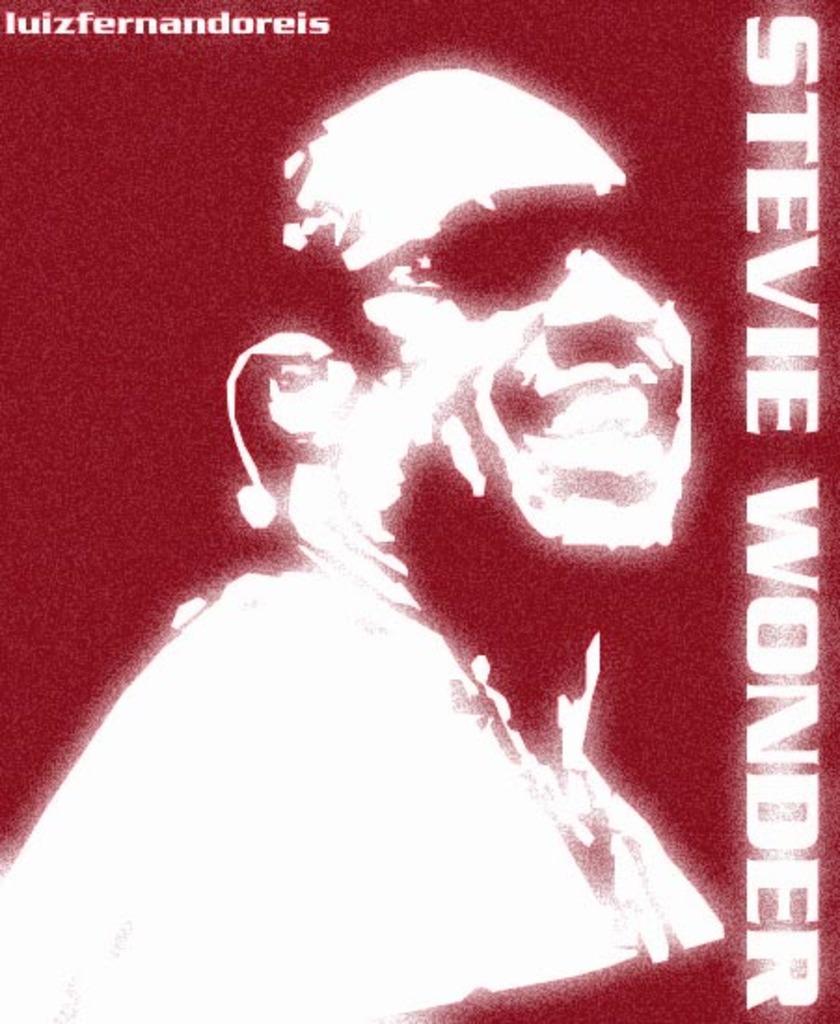How would you summarize this image in a sentence or two? This is an edited image and here we can see a man smiling and wearing glasses and there is some text. 